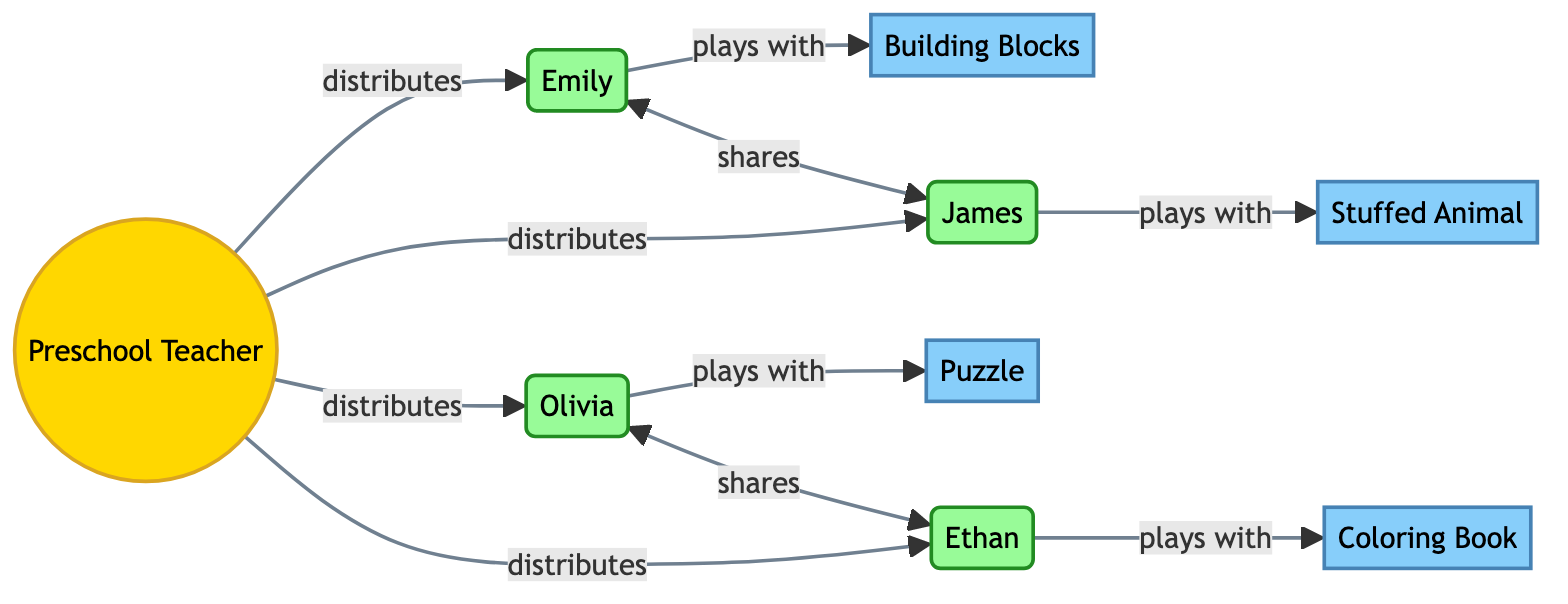What is the total number of participants in the diagram? The diagram includes four children, which represent the participants in the playtime scenario. By counting the nodes labeled as participants, we find there are Emily, James, Olivia, and Ethan.
Answer: 4 Which toy is associated with Child: Emily? The edge from Child: Emily points to the Toy: Building Blocks, indicating this is the toy that Emily plays with.
Answer: Building Blocks Who shares toys with Child: James? In the diagram, Child: Emily shares toys with Child: James, as indicated by the edge connecting their nodes with the "shares" relationship.
Answer: Emily How many toys are present in the diagram? The diagram lists four different toys: Building Blocks, Stuffed Animal, Puzzle, and Coloring Book. Counting the nodes labeled as toys gives us the total number of toys.
Answer: 4 What is the relationship between the Preschool Teacher and the children? The edges from the Preschool Teacher to each child specify the relationship as "distributes", signifying that the teacher distributes toys to the children.
Answer: distributes Which two children share toys with each other? The diagram reveals that Child: Emily shares with Child: James, and Child: Olivia shares with Child: Ethan. Both relationships are indicated by "shares."
Answer: Emily and James, Olivia and Ethan How many total connections (edges) are there in the diagram? By counting all the edges shown in the diagram that connect nodes, we notice there are eight connections: four from the teacher to the children, four between children and toys, and two sharing connections.
Answer: 8 Which toy do Child: Olivia and Child: Ethan each play with? Child: Olivia plays with the Toy: Puzzle, and Child: Ethan plays with the Toy: Coloring Book. The edges from these children point to their respective toys in the diagram.
Answer: Puzzle and Coloring Book 